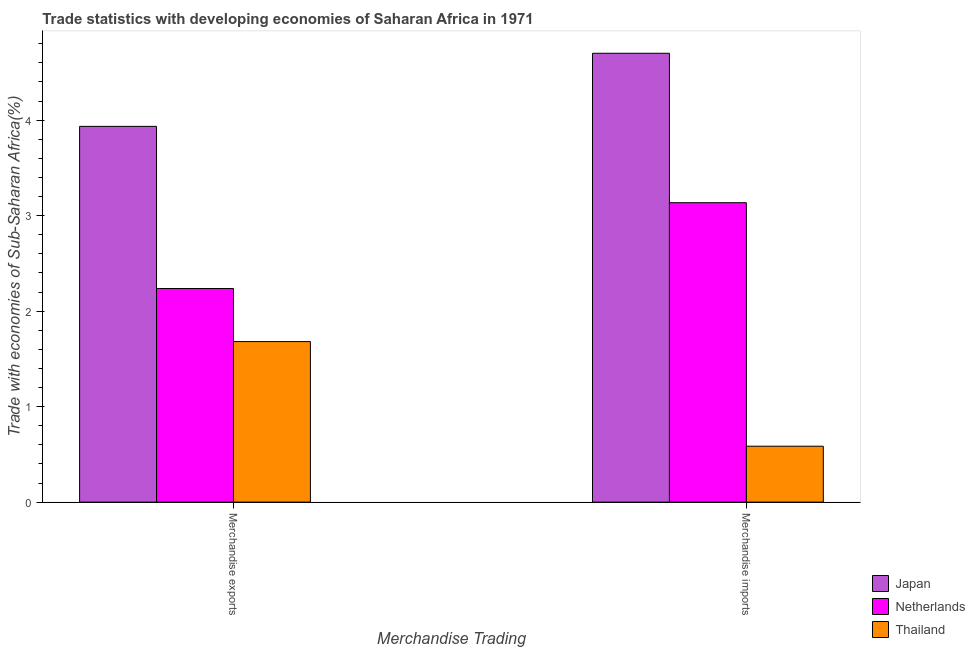How many groups of bars are there?
Keep it short and to the point. 2. How many bars are there on the 2nd tick from the left?
Your answer should be very brief. 3. What is the label of the 1st group of bars from the left?
Give a very brief answer. Merchandise exports. What is the merchandise imports in Japan?
Your response must be concise. 4.7. Across all countries, what is the maximum merchandise exports?
Keep it short and to the point. 3.93. Across all countries, what is the minimum merchandise exports?
Provide a succinct answer. 1.68. In which country was the merchandise imports minimum?
Give a very brief answer. Thailand. What is the total merchandise imports in the graph?
Keep it short and to the point. 8.42. What is the difference between the merchandise imports in Thailand and that in Japan?
Give a very brief answer. -4.11. What is the difference between the merchandise exports in Japan and the merchandise imports in Thailand?
Keep it short and to the point. 3.35. What is the average merchandise exports per country?
Your response must be concise. 2.62. What is the difference between the merchandise exports and merchandise imports in Thailand?
Offer a very short reply. 1.1. In how many countries, is the merchandise imports greater than 3 %?
Provide a short and direct response. 2. What is the ratio of the merchandise imports in Japan to that in Thailand?
Provide a short and direct response. 8.03. Is the merchandise imports in Netherlands less than that in Japan?
Offer a terse response. Yes. Are all the bars in the graph horizontal?
Your response must be concise. No. What is the difference between two consecutive major ticks on the Y-axis?
Offer a terse response. 1. Does the graph contain any zero values?
Make the answer very short. No. Where does the legend appear in the graph?
Make the answer very short. Bottom right. How many legend labels are there?
Provide a succinct answer. 3. What is the title of the graph?
Provide a short and direct response. Trade statistics with developing economies of Saharan Africa in 1971. What is the label or title of the X-axis?
Your answer should be compact. Merchandise Trading. What is the label or title of the Y-axis?
Your response must be concise. Trade with economies of Sub-Saharan Africa(%). What is the Trade with economies of Sub-Saharan Africa(%) of Japan in Merchandise exports?
Offer a very short reply. 3.93. What is the Trade with economies of Sub-Saharan Africa(%) in Netherlands in Merchandise exports?
Offer a terse response. 2.24. What is the Trade with economies of Sub-Saharan Africa(%) of Thailand in Merchandise exports?
Offer a terse response. 1.68. What is the Trade with economies of Sub-Saharan Africa(%) in Japan in Merchandise imports?
Provide a short and direct response. 4.7. What is the Trade with economies of Sub-Saharan Africa(%) in Netherlands in Merchandise imports?
Your response must be concise. 3.14. What is the Trade with economies of Sub-Saharan Africa(%) in Thailand in Merchandise imports?
Your answer should be compact. 0.59. Across all Merchandise Trading, what is the maximum Trade with economies of Sub-Saharan Africa(%) in Japan?
Provide a succinct answer. 4.7. Across all Merchandise Trading, what is the maximum Trade with economies of Sub-Saharan Africa(%) of Netherlands?
Your response must be concise. 3.14. Across all Merchandise Trading, what is the maximum Trade with economies of Sub-Saharan Africa(%) of Thailand?
Make the answer very short. 1.68. Across all Merchandise Trading, what is the minimum Trade with economies of Sub-Saharan Africa(%) of Japan?
Your response must be concise. 3.93. Across all Merchandise Trading, what is the minimum Trade with economies of Sub-Saharan Africa(%) of Netherlands?
Offer a very short reply. 2.24. Across all Merchandise Trading, what is the minimum Trade with economies of Sub-Saharan Africa(%) in Thailand?
Your answer should be compact. 0.59. What is the total Trade with economies of Sub-Saharan Africa(%) in Japan in the graph?
Offer a very short reply. 8.63. What is the total Trade with economies of Sub-Saharan Africa(%) of Netherlands in the graph?
Offer a very short reply. 5.37. What is the total Trade with economies of Sub-Saharan Africa(%) in Thailand in the graph?
Offer a very short reply. 2.27. What is the difference between the Trade with economies of Sub-Saharan Africa(%) of Japan in Merchandise exports and that in Merchandise imports?
Offer a very short reply. -0.77. What is the difference between the Trade with economies of Sub-Saharan Africa(%) of Netherlands in Merchandise exports and that in Merchandise imports?
Provide a succinct answer. -0.9. What is the difference between the Trade with economies of Sub-Saharan Africa(%) of Thailand in Merchandise exports and that in Merchandise imports?
Offer a terse response. 1.1. What is the difference between the Trade with economies of Sub-Saharan Africa(%) in Japan in Merchandise exports and the Trade with economies of Sub-Saharan Africa(%) in Netherlands in Merchandise imports?
Provide a succinct answer. 0.8. What is the difference between the Trade with economies of Sub-Saharan Africa(%) in Japan in Merchandise exports and the Trade with economies of Sub-Saharan Africa(%) in Thailand in Merchandise imports?
Your answer should be very brief. 3.35. What is the difference between the Trade with economies of Sub-Saharan Africa(%) in Netherlands in Merchandise exports and the Trade with economies of Sub-Saharan Africa(%) in Thailand in Merchandise imports?
Offer a terse response. 1.65. What is the average Trade with economies of Sub-Saharan Africa(%) in Japan per Merchandise Trading?
Offer a very short reply. 4.32. What is the average Trade with economies of Sub-Saharan Africa(%) of Netherlands per Merchandise Trading?
Your answer should be compact. 2.69. What is the average Trade with economies of Sub-Saharan Africa(%) in Thailand per Merchandise Trading?
Provide a short and direct response. 1.13. What is the difference between the Trade with economies of Sub-Saharan Africa(%) in Japan and Trade with economies of Sub-Saharan Africa(%) in Netherlands in Merchandise exports?
Your answer should be compact. 1.7. What is the difference between the Trade with economies of Sub-Saharan Africa(%) in Japan and Trade with economies of Sub-Saharan Africa(%) in Thailand in Merchandise exports?
Provide a succinct answer. 2.25. What is the difference between the Trade with economies of Sub-Saharan Africa(%) in Netherlands and Trade with economies of Sub-Saharan Africa(%) in Thailand in Merchandise exports?
Provide a succinct answer. 0.56. What is the difference between the Trade with economies of Sub-Saharan Africa(%) of Japan and Trade with economies of Sub-Saharan Africa(%) of Netherlands in Merchandise imports?
Provide a succinct answer. 1.56. What is the difference between the Trade with economies of Sub-Saharan Africa(%) in Japan and Trade with economies of Sub-Saharan Africa(%) in Thailand in Merchandise imports?
Give a very brief answer. 4.11. What is the difference between the Trade with economies of Sub-Saharan Africa(%) in Netherlands and Trade with economies of Sub-Saharan Africa(%) in Thailand in Merchandise imports?
Offer a terse response. 2.55. What is the ratio of the Trade with economies of Sub-Saharan Africa(%) of Japan in Merchandise exports to that in Merchandise imports?
Provide a succinct answer. 0.84. What is the ratio of the Trade with economies of Sub-Saharan Africa(%) of Netherlands in Merchandise exports to that in Merchandise imports?
Your answer should be compact. 0.71. What is the ratio of the Trade with economies of Sub-Saharan Africa(%) of Thailand in Merchandise exports to that in Merchandise imports?
Ensure brevity in your answer.  2.87. What is the difference between the highest and the second highest Trade with economies of Sub-Saharan Africa(%) in Japan?
Make the answer very short. 0.77. What is the difference between the highest and the second highest Trade with economies of Sub-Saharan Africa(%) of Netherlands?
Keep it short and to the point. 0.9. What is the difference between the highest and the second highest Trade with economies of Sub-Saharan Africa(%) in Thailand?
Your response must be concise. 1.1. What is the difference between the highest and the lowest Trade with economies of Sub-Saharan Africa(%) of Japan?
Keep it short and to the point. 0.77. What is the difference between the highest and the lowest Trade with economies of Sub-Saharan Africa(%) of Netherlands?
Give a very brief answer. 0.9. What is the difference between the highest and the lowest Trade with economies of Sub-Saharan Africa(%) of Thailand?
Keep it short and to the point. 1.1. 